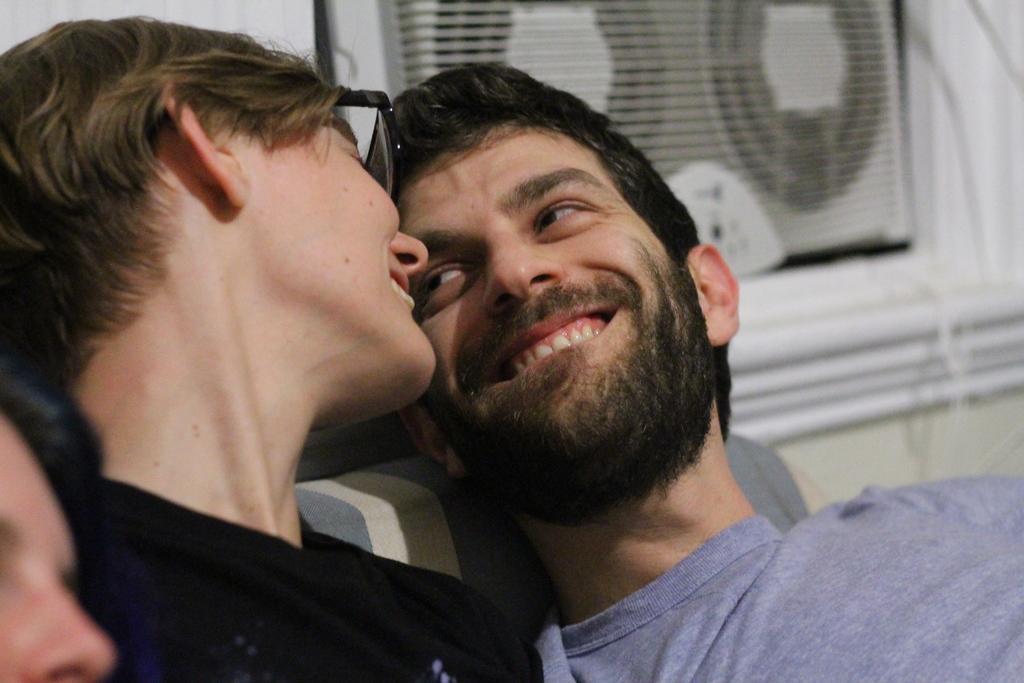Can you describe this image briefly? In this picture I can see a woman and a man in front and I see that both of them are smiling. In the background I can see the white color thing. On the bottom left corner of this picture I can see a person's face. 